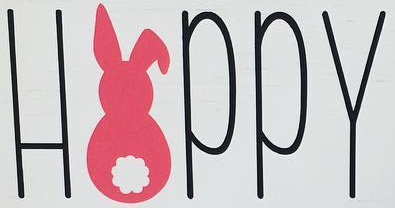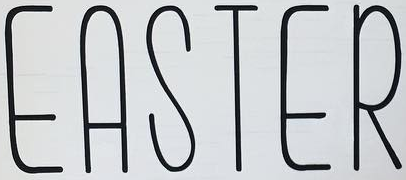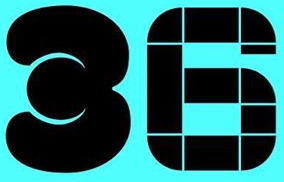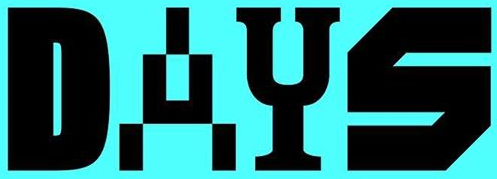Read the text content from these images in order, separated by a semicolon. HAPPY; EASTER; 36; DAYS 